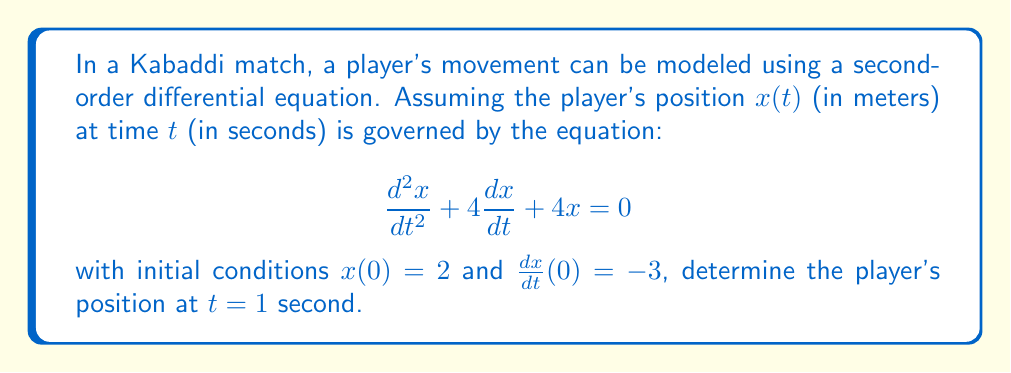Show me your answer to this math problem. To solve this problem, we'll follow these steps:

1) The given differential equation is of the form:
   $$\frac{d^2x}{dt^2} + 2a\frac{dx}{dt} + a^2x = 0$$
   where $a = 2$. This is a second-order linear homogeneous differential equation with constant coefficients.

2) The characteristic equation is:
   $$r^2 + 4r + 4 = 0$$

3) Solving this quadratic equation:
   $$(r + 2)^2 = 0$$
   $r = -2$ (repeated root)

4) The general solution for a repeated root is:
   $$x(t) = (C_1 + C_2t)e^{-2t}$$

5) Using the initial conditions to find $C_1$ and $C_2$:
   
   For $x(0) = 2$:
   $$2 = C_1 + 0 \cdot C_2 \implies C_1 = 2$$

   For $\frac{dx}{dt}(0) = -3$:
   $$\frac{dx}{dt} = (-2C_1 - 2C_2t + C_2)e^{-2t}$$
   $$-3 = -2C_1 + C_2 = -4 + C_2 \implies C_2 = 1$$

6) Therefore, the particular solution is:
   $$x(t) = (2 + t)e^{-2t}$$

7) To find the position at $t = 1$:
   $$x(1) = (2 + 1)e^{-2(1)} = 3e^{-2} \approx 0.4060$$
Answer: $x(1) \approx 0.4060$ meters 